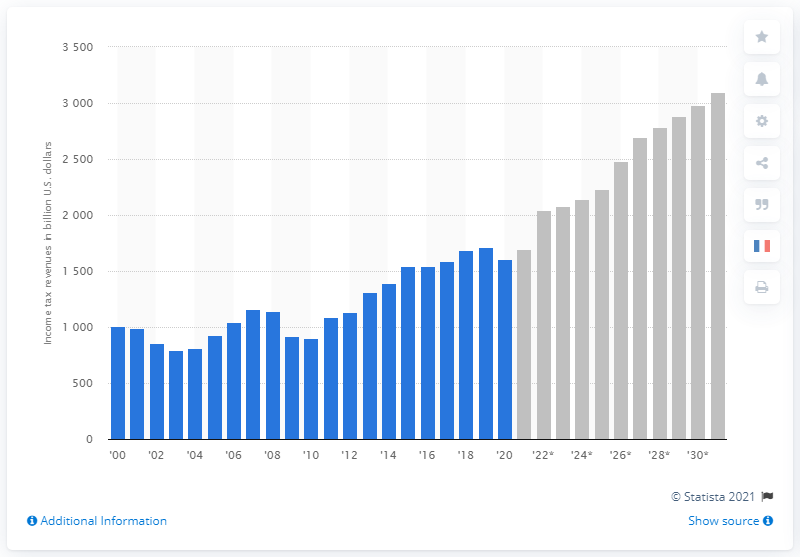Mention a couple of crucial points in this snapshot. By 2031, it is projected that the income tax revenues will increase. In 2020, the income tax revenue in the United States was approximately 1609. 